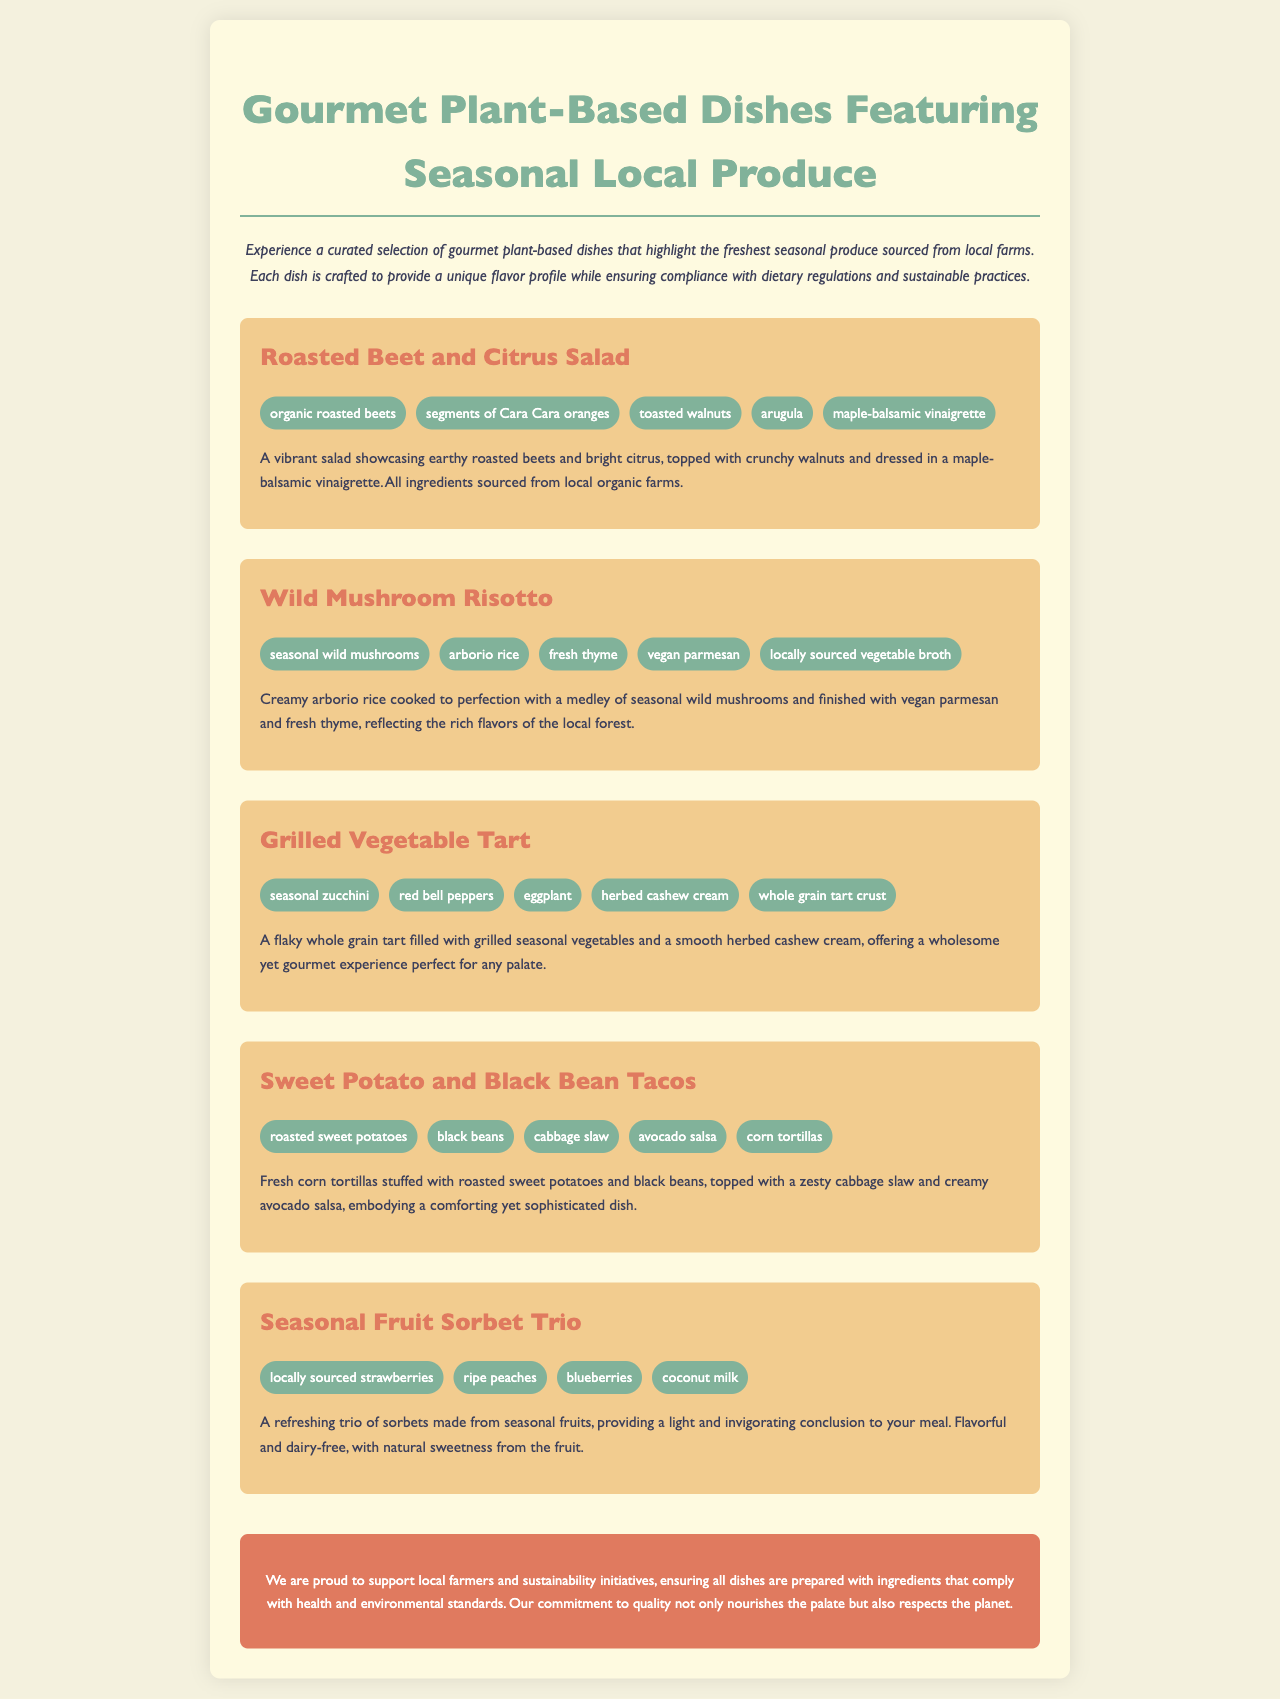What is the first dish listed? The first dish listed in the menu is "Roasted Beet and Citrus Salad."
Answer: Roasted Beet and Citrus Salad How many ingredients are in the Wild Mushroom Risotto? The Wild Mushroom Risotto has five ingredients mentioned in the document.
Answer: 5 What is the main ingredient of the sorbet trio? The main ingredients of the sorbet trio are seasonal fruits, specifically strawberries, peaches, and blueberries.
Answer: Strawberries, peaches, blueberries Which dish includes avocado salsa? The dish that includes avocado salsa is "Sweet Potato and Black Bean Tacos."
Answer: Sweet Potato and Black Bean Tacos What type of broth is used in the Wild Mushroom Risotto? The type of broth used in the Wild Mushroom Risotto is "locally sourced vegetable broth."
Answer: locally sourced vegetable broth How do the dishes in the menu support sustainability? The dishes support sustainability by using ingredients sourced from local farms, complying with health and environmental standards.
Answer: Local farms What is the theme of the menu? The theme of the menu is "Gourmet Plant-Based Dishes Featuring Seasonal Local Produce."
Answer: Gourmet Plant-Based Dishes Featuring Seasonal Local Produce What is the main focus of the dessert option? The main focus of the dessert option is a refreshing trio of sorbets made from seasonal fruits.
Answer: Seasonal fruits 